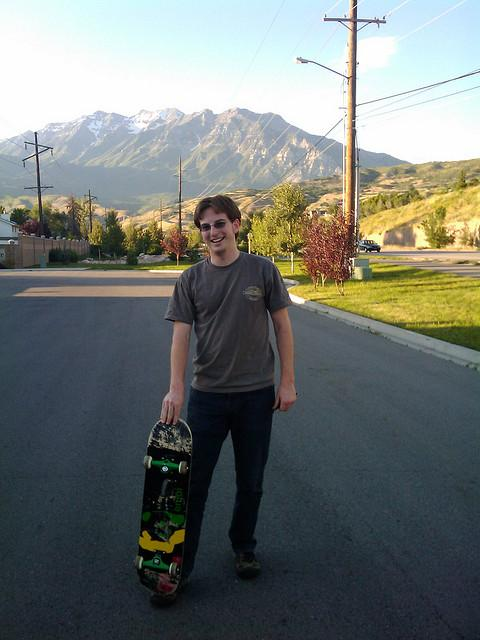What setting does the boarder pose in here?

Choices:
A) urban
B) suburban
C) desert
D) farm suburban 